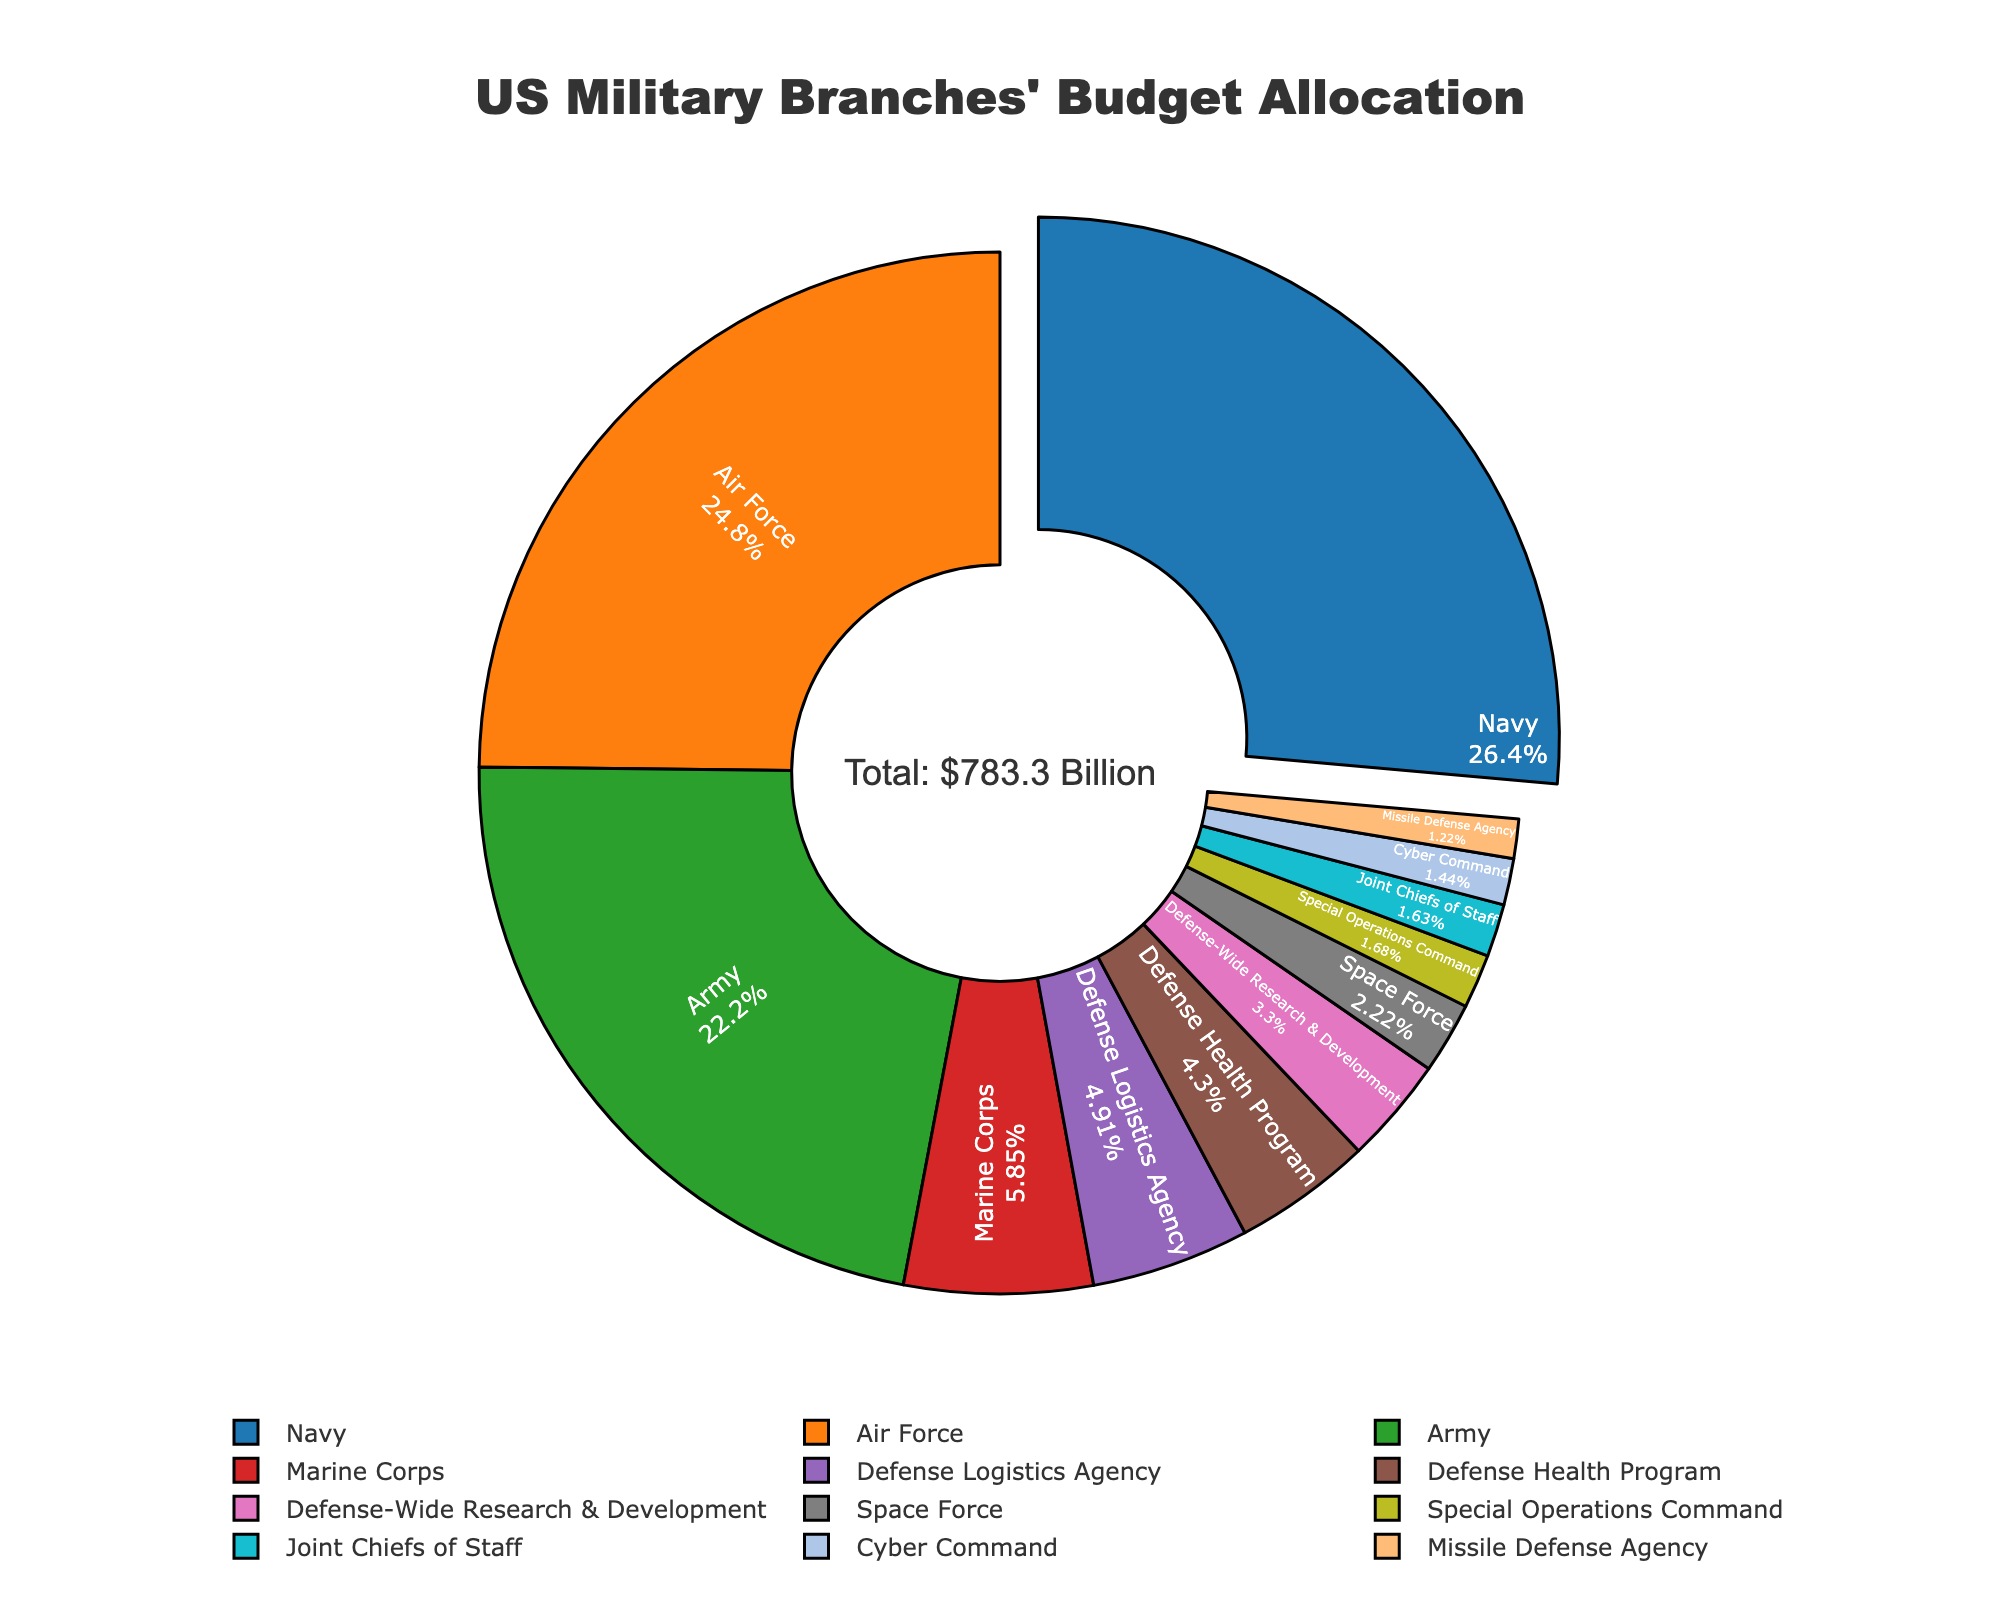Which branch has the largest budget allocation? To find which branch has the largest budget allocation, we look for the segment that is pulled out the most in the pie chart, which indicates the largest budget allocation. The Navy has the largest budget allocation.
Answer: Navy What percentage of the total budget does the Air Force allocate? We look at the segment of the Air Force in the pie chart and find its percentage value. The Air Force allocates 24.83% of the total budget.
Answer: 24.83% How does the budget allocation for the Army compare to that of the Marine Corps? To compare the budget allocations, we look at their respective segments in the pie chart. The Army's segment is much larger than the Marine Corps'. The Army has a budget allocation of $174.2 billion, while the Marine Corps has $45.9 billion.
Answer: Army's budget is significantly larger than Marine Corps' Which two branches have the closest budget allocations? To determine this, we need to compare the values from the pie chart and identify the two branches with the smallest difference. The Army and Air Force have the closest budget allocations with $174.2 billion and $194.6 billion respectively.
Answer: Army and Air Force What is the total budget allocation of the Missile Defense Agency and Cyber Command combined? We add the budget allocations of the Missile Defense Agency ($9.6 billion) and Cyber Command ($11.3 billion). The sum is $20.9 billion.
Answer: $20.9 billion Which branch has the smallest budget allocation, and what is the percentage of the total budget? We look at the smallest segment in the pie chart, which represents the smallest budget allocation. The Joint Chiefs of Staff has the smallest budget allocation. We check its percentage value, which is 1.63%.
Answer: Joint Chiefs of Staff, 1.63% How does the budget allocation for the Defense Logistics Agency compare visually to that of the Defense Health Program? We need to look at the relative sizes of their segments in the pie chart. The Defense Logistics Agency's segment is slightly larger than the Defense Health Program's.
Answer: Defense Logistics Agency has a slightly larger segment than Defense Health Program What is the combined percentage of the budget allocations for Space Force and Special Operations Command? We need to sum their percentages from the pie chart. Space Force allocates 2.22% and Special Operations Command allocates 1.69%. The combined percentage is 3.91%.
Answer: 3.91% How much more is allocated to the Navy compared to the Defense-Wide Research & Development? We subtract the amount allocated to Defense-Wide Research & Development ($25.9 billion) from the amount allocated to the Navy ($207.1 billion). The difference is $181.2 billion.
Answer: $181.2 billion Which branch has a budget allocation closest to the Defense Health Program visually? We look for segments in the pie chart that are close in size to the Defense Health Program's segment. The Defense Logistics Agency's segment is closest visually.
Answer: Defense Logistics Agency 